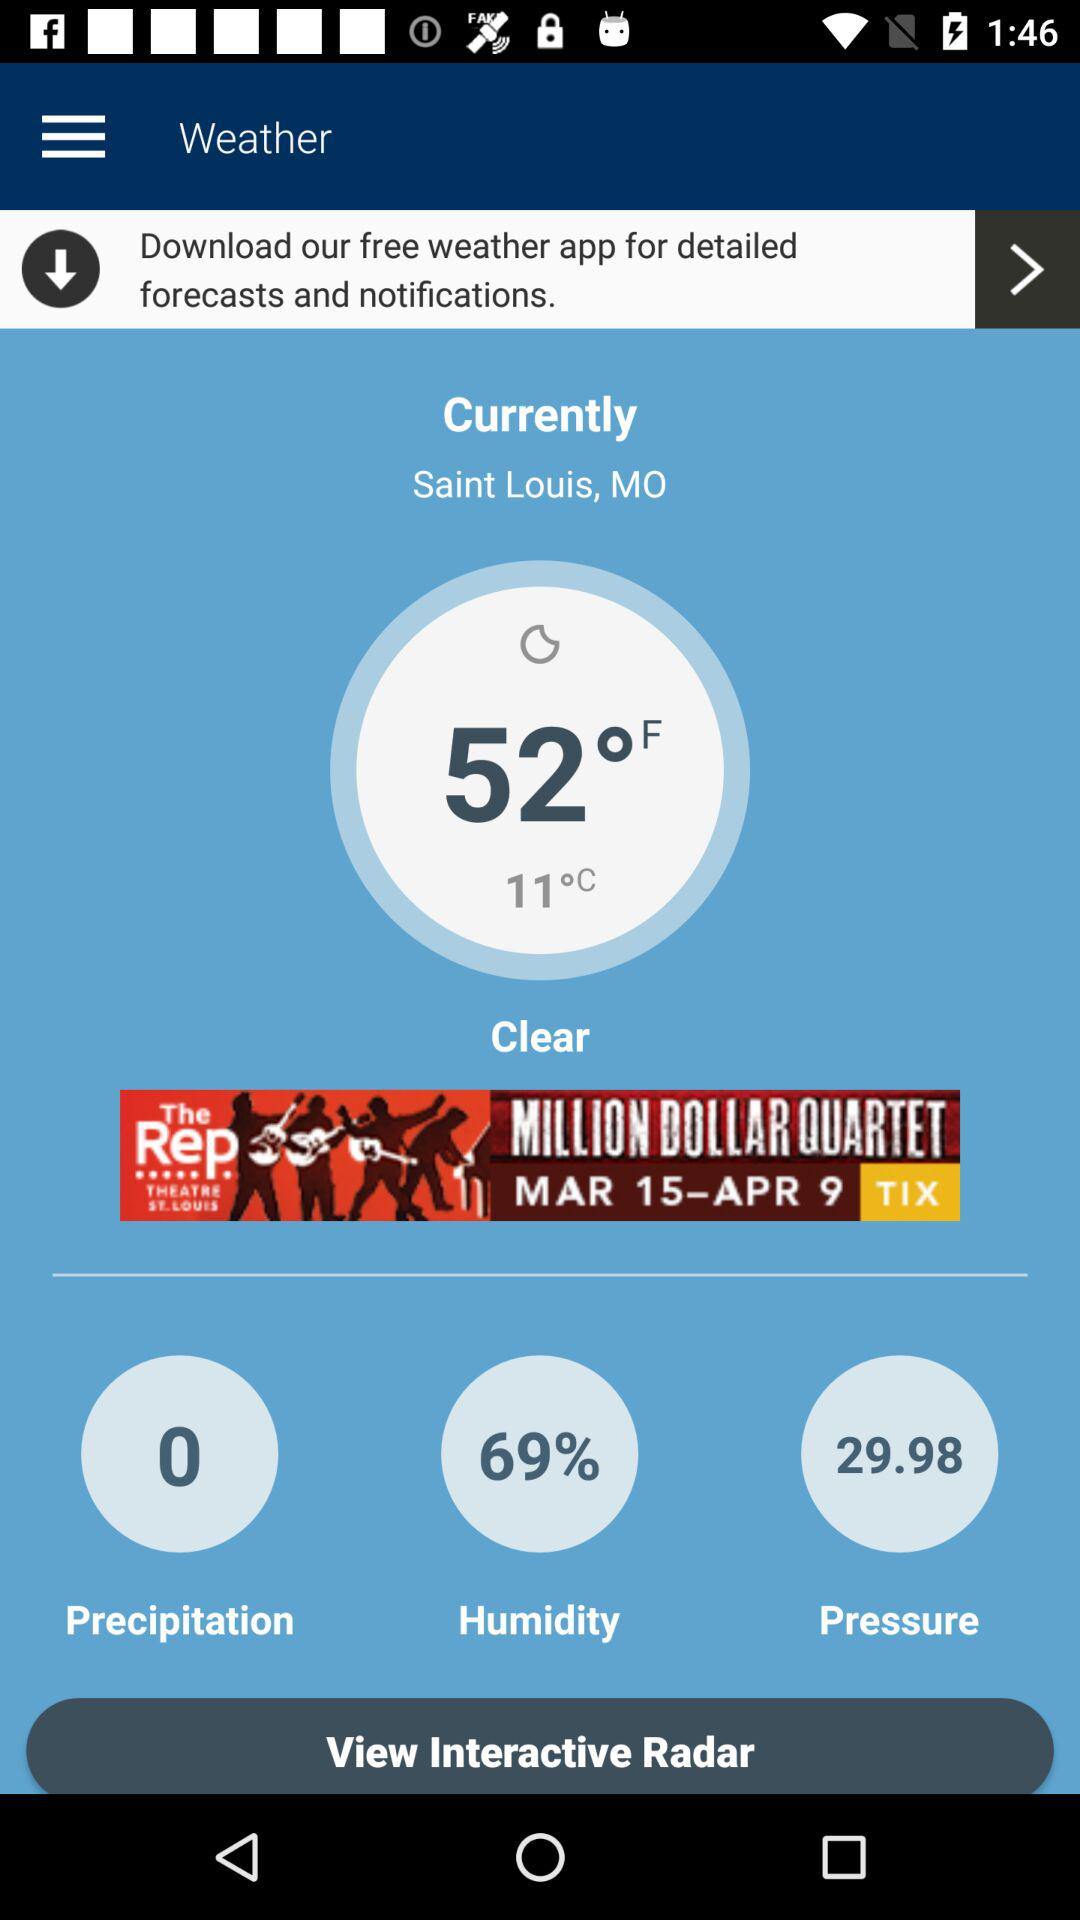What's the pressure? The pressure is 29.98. 